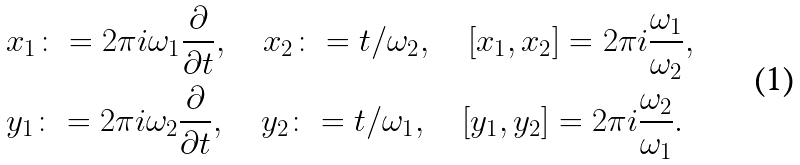Convert formula to latex. <formula><loc_0><loc_0><loc_500><loc_500>& x _ { 1 } \colon = 2 \pi i \omega _ { 1 } \frac { \partial } { \partial t } , \quad x _ { 2 } \colon = t / \omega _ { 2 } , \quad [ x _ { 1 } , x _ { 2 } ] = 2 \pi i \frac { \omega _ { 1 } } { \omega _ { 2 } } , \\ & y _ { 1 } \colon = 2 \pi i \omega _ { 2 } \frac { \partial } { \partial t } , \quad y _ { 2 } \colon = t / \omega _ { 1 } , \quad [ y _ { 1 } , y _ { 2 } ] = 2 \pi i \frac { \omega _ { 2 } } { \omega _ { 1 } } . \\</formula> 